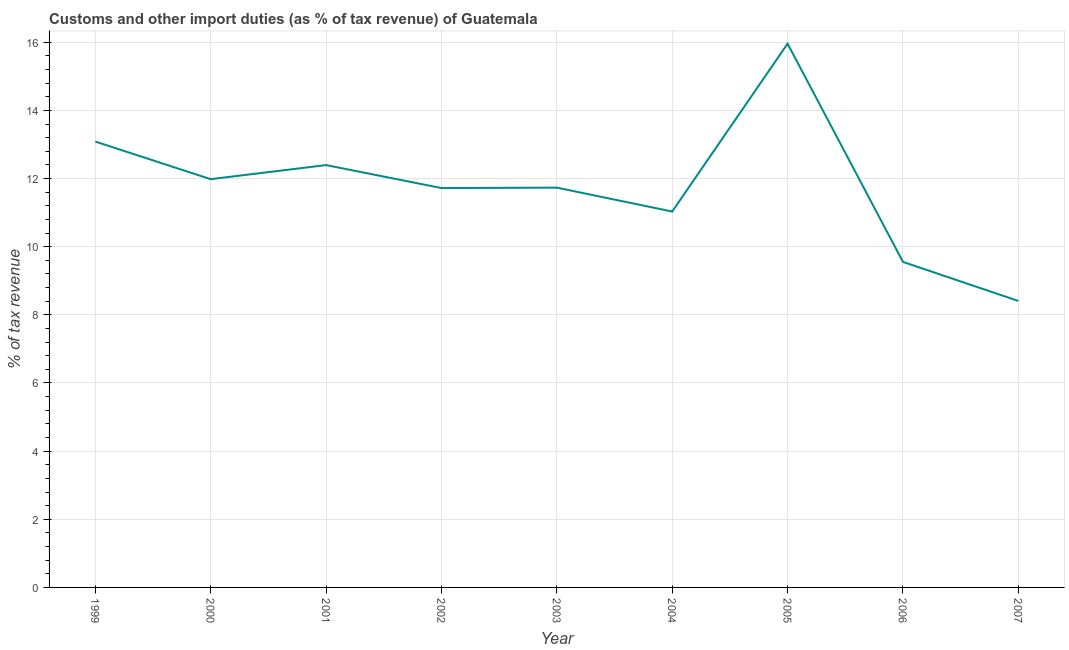What is the customs and other import duties in 2005?
Your answer should be very brief. 15.96. Across all years, what is the maximum customs and other import duties?
Provide a short and direct response. 15.96. Across all years, what is the minimum customs and other import duties?
Offer a terse response. 8.41. In which year was the customs and other import duties maximum?
Give a very brief answer. 2005. What is the sum of the customs and other import duties?
Your answer should be compact. 105.87. What is the difference between the customs and other import duties in 2000 and 2003?
Offer a terse response. 0.25. What is the average customs and other import duties per year?
Keep it short and to the point. 11.76. What is the median customs and other import duties?
Keep it short and to the point. 11.73. In how many years, is the customs and other import duties greater than 12.8 %?
Ensure brevity in your answer.  2. Do a majority of the years between 1999 and 2000 (inclusive) have customs and other import duties greater than 14 %?
Ensure brevity in your answer.  No. What is the ratio of the customs and other import duties in 2003 to that in 2004?
Make the answer very short. 1.06. Is the customs and other import duties in 2000 less than that in 2004?
Offer a very short reply. No. Is the difference between the customs and other import duties in 2004 and 2005 greater than the difference between any two years?
Make the answer very short. No. What is the difference between the highest and the second highest customs and other import duties?
Ensure brevity in your answer.  2.87. Is the sum of the customs and other import duties in 2001 and 2006 greater than the maximum customs and other import duties across all years?
Your response must be concise. Yes. What is the difference between the highest and the lowest customs and other import duties?
Keep it short and to the point. 7.55. Does the customs and other import duties monotonically increase over the years?
Provide a succinct answer. No. How many years are there in the graph?
Your response must be concise. 9. What is the difference between two consecutive major ticks on the Y-axis?
Offer a very short reply. 2. Are the values on the major ticks of Y-axis written in scientific E-notation?
Provide a short and direct response. No. Does the graph contain any zero values?
Keep it short and to the point. No. What is the title of the graph?
Provide a succinct answer. Customs and other import duties (as % of tax revenue) of Guatemala. What is the label or title of the Y-axis?
Keep it short and to the point. % of tax revenue. What is the % of tax revenue of 1999?
Keep it short and to the point. 13.09. What is the % of tax revenue of 2000?
Make the answer very short. 11.98. What is the % of tax revenue in 2001?
Provide a succinct answer. 12.4. What is the % of tax revenue of 2002?
Provide a short and direct response. 11.72. What is the % of tax revenue in 2003?
Your response must be concise. 11.73. What is the % of tax revenue in 2004?
Your response must be concise. 11.03. What is the % of tax revenue in 2005?
Your answer should be very brief. 15.96. What is the % of tax revenue of 2006?
Give a very brief answer. 9.55. What is the % of tax revenue in 2007?
Offer a very short reply. 8.41. What is the difference between the % of tax revenue in 1999 and 2000?
Your answer should be very brief. 1.1. What is the difference between the % of tax revenue in 1999 and 2001?
Ensure brevity in your answer.  0.69. What is the difference between the % of tax revenue in 1999 and 2002?
Offer a very short reply. 1.36. What is the difference between the % of tax revenue in 1999 and 2003?
Ensure brevity in your answer.  1.35. What is the difference between the % of tax revenue in 1999 and 2004?
Provide a succinct answer. 2.05. What is the difference between the % of tax revenue in 1999 and 2005?
Ensure brevity in your answer.  -2.87. What is the difference between the % of tax revenue in 1999 and 2006?
Your answer should be compact. 3.53. What is the difference between the % of tax revenue in 1999 and 2007?
Your answer should be very brief. 4.68. What is the difference between the % of tax revenue in 2000 and 2001?
Your response must be concise. -0.41. What is the difference between the % of tax revenue in 2000 and 2002?
Provide a short and direct response. 0.26. What is the difference between the % of tax revenue in 2000 and 2003?
Your response must be concise. 0.25. What is the difference between the % of tax revenue in 2000 and 2004?
Keep it short and to the point. 0.95. What is the difference between the % of tax revenue in 2000 and 2005?
Ensure brevity in your answer.  -3.98. What is the difference between the % of tax revenue in 2000 and 2006?
Provide a succinct answer. 2.43. What is the difference between the % of tax revenue in 2000 and 2007?
Offer a terse response. 3.57. What is the difference between the % of tax revenue in 2001 and 2002?
Offer a terse response. 0.67. What is the difference between the % of tax revenue in 2001 and 2003?
Offer a terse response. 0.66. What is the difference between the % of tax revenue in 2001 and 2004?
Keep it short and to the point. 1.36. What is the difference between the % of tax revenue in 2001 and 2005?
Ensure brevity in your answer.  -3.56. What is the difference between the % of tax revenue in 2001 and 2006?
Your answer should be compact. 2.84. What is the difference between the % of tax revenue in 2001 and 2007?
Keep it short and to the point. 3.99. What is the difference between the % of tax revenue in 2002 and 2003?
Provide a short and direct response. -0.01. What is the difference between the % of tax revenue in 2002 and 2004?
Make the answer very short. 0.69. What is the difference between the % of tax revenue in 2002 and 2005?
Your answer should be compact. -4.24. What is the difference between the % of tax revenue in 2002 and 2006?
Keep it short and to the point. 2.17. What is the difference between the % of tax revenue in 2002 and 2007?
Offer a terse response. 3.31. What is the difference between the % of tax revenue in 2003 and 2004?
Make the answer very short. 0.7. What is the difference between the % of tax revenue in 2003 and 2005?
Make the answer very short. -4.22. What is the difference between the % of tax revenue in 2003 and 2006?
Provide a succinct answer. 2.18. What is the difference between the % of tax revenue in 2003 and 2007?
Provide a succinct answer. 3.33. What is the difference between the % of tax revenue in 2004 and 2005?
Ensure brevity in your answer.  -4.93. What is the difference between the % of tax revenue in 2004 and 2006?
Make the answer very short. 1.48. What is the difference between the % of tax revenue in 2004 and 2007?
Give a very brief answer. 2.62. What is the difference between the % of tax revenue in 2005 and 2006?
Keep it short and to the point. 6.4. What is the difference between the % of tax revenue in 2005 and 2007?
Your answer should be very brief. 7.55. What is the difference between the % of tax revenue in 2006 and 2007?
Make the answer very short. 1.15. What is the ratio of the % of tax revenue in 1999 to that in 2000?
Ensure brevity in your answer.  1.09. What is the ratio of the % of tax revenue in 1999 to that in 2001?
Provide a short and direct response. 1.06. What is the ratio of the % of tax revenue in 1999 to that in 2002?
Keep it short and to the point. 1.12. What is the ratio of the % of tax revenue in 1999 to that in 2003?
Provide a succinct answer. 1.11. What is the ratio of the % of tax revenue in 1999 to that in 2004?
Provide a short and direct response. 1.19. What is the ratio of the % of tax revenue in 1999 to that in 2005?
Ensure brevity in your answer.  0.82. What is the ratio of the % of tax revenue in 1999 to that in 2006?
Give a very brief answer. 1.37. What is the ratio of the % of tax revenue in 1999 to that in 2007?
Offer a very short reply. 1.56. What is the ratio of the % of tax revenue in 2000 to that in 2001?
Make the answer very short. 0.97. What is the ratio of the % of tax revenue in 2000 to that in 2004?
Provide a short and direct response. 1.09. What is the ratio of the % of tax revenue in 2000 to that in 2005?
Make the answer very short. 0.75. What is the ratio of the % of tax revenue in 2000 to that in 2006?
Give a very brief answer. 1.25. What is the ratio of the % of tax revenue in 2000 to that in 2007?
Offer a terse response. 1.43. What is the ratio of the % of tax revenue in 2001 to that in 2002?
Ensure brevity in your answer.  1.06. What is the ratio of the % of tax revenue in 2001 to that in 2003?
Provide a short and direct response. 1.06. What is the ratio of the % of tax revenue in 2001 to that in 2004?
Make the answer very short. 1.12. What is the ratio of the % of tax revenue in 2001 to that in 2005?
Give a very brief answer. 0.78. What is the ratio of the % of tax revenue in 2001 to that in 2006?
Provide a succinct answer. 1.3. What is the ratio of the % of tax revenue in 2001 to that in 2007?
Ensure brevity in your answer.  1.47. What is the ratio of the % of tax revenue in 2002 to that in 2003?
Provide a short and direct response. 1. What is the ratio of the % of tax revenue in 2002 to that in 2004?
Ensure brevity in your answer.  1.06. What is the ratio of the % of tax revenue in 2002 to that in 2005?
Give a very brief answer. 0.73. What is the ratio of the % of tax revenue in 2002 to that in 2006?
Give a very brief answer. 1.23. What is the ratio of the % of tax revenue in 2002 to that in 2007?
Provide a short and direct response. 1.39. What is the ratio of the % of tax revenue in 2003 to that in 2004?
Provide a short and direct response. 1.06. What is the ratio of the % of tax revenue in 2003 to that in 2005?
Offer a very short reply. 0.73. What is the ratio of the % of tax revenue in 2003 to that in 2006?
Your answer should be very brief. 1.23. What is the ratio of the % of tax revenue in 2003 to that in 2007?
Make the answer very short. 1.4. What is the ratio of the % of tax revenue in 2004 to that in 2005?
Your response must be concise. 0.69. What is the ratio of the % of tax revenue in 2004 to that in 2006?
Your answer should be compact. 1.16. What is the ratio of the % of tax revenue in 2004 to that in 2007?
Your answer should be very brief. 1.31. What is the ratio of the % of tax revenue in 2005 to that in 2006?
Your response must be concise. 1.67. What is the ratio of the % of tax revenue in 2005 to that in 2007?
Offer a very short reply. 1.9. What is the ratio of the % of tax revenue in 2006 to that in 2007?
Keep it short and to the point. 1.14. 